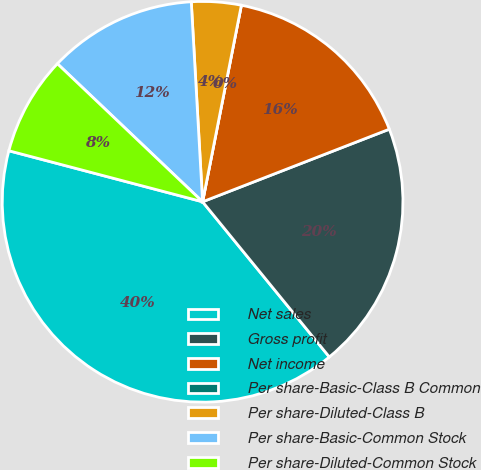Convert chart to OTSL. <chart><loc_0><loc_0><loc_500><loc_500><pie_chart><fcel>Net sales<fcel>Gross profit<fcel>Net income<fcel>Per share-Basic-Class B Common<fcel>Per share-Diluted-Class B<fcel>Per share-Basic-Common Stock<fcel>Per share-Diluted-Common Stock<nl><fcel>40.0%<fcel>20.0%<fcel>16.0%<fcel>0.0%<fcel>4.0%<fcel>12.0%<fcel>8.0%<nl></chart> 